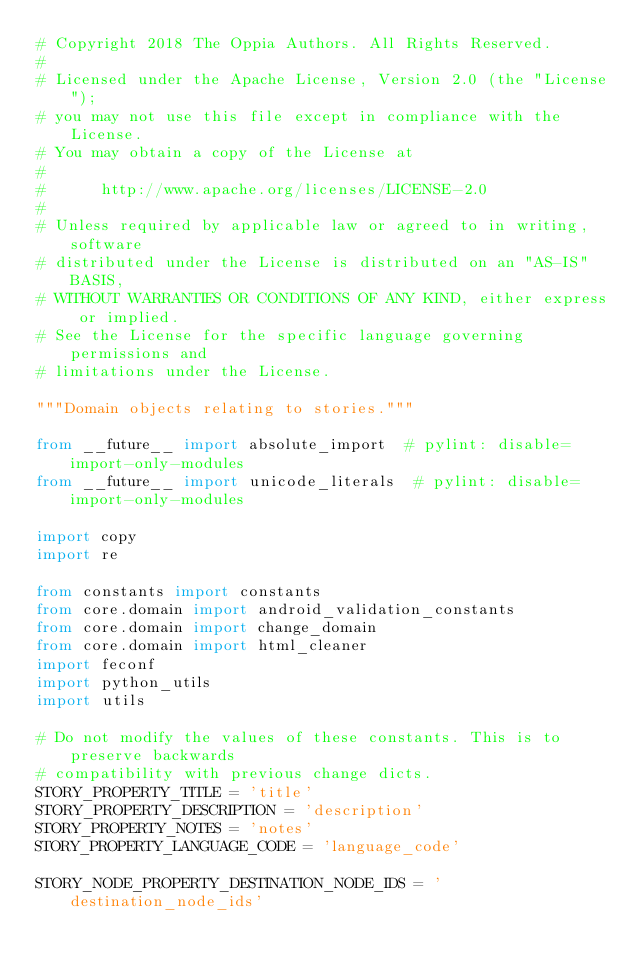<code> <loc_0><loc_0><loc_500><loc_500><_Python_># Copyright 2018 The Oppia Authors. All Rights Reserved.
#
# Licensed under the Apache License, Version 2.0 (the "License");
# you may not use this file except in compliance with the License.
# You may obtain a copy of the License at
#
#      http://www.apache.org/licenses/LICENSE-2.0
#
# Unless required by applicable law or agreed to in writing, software
# distributed under the License is distributed on an "AS-IS" BASIS,
# WITHOUT WARRANTIES OR CONDITIONS OF ANY KIND, either express or implied.
# See the License for the specific language governing permissions and
# limitations under the License.

"""Domain objects relating to stories."""

from __future__ import absolute_import  # pylint: disable=import-only-modules
from __future__ import unicode_literals  # pylint: disable=import-only-modules

import copy
import re

from constants import constants
from core.domain import android_validation_constants
from core.domain import change_domain
from core.domain import html_cleaner
import feconf
import python_utils
import utils

# Do not modify the values of these constants. This is to preserve backwards
# compatibility with previous change dicts.
STORY_PROPERTY_TITLE = 'title'
STORY_PROPERTY_DESCRIPTION = 'description'
STORY_PROPERTY_NOTES = 'notes'
STORY_PROPERTY_LANGUAGE_CODE = 'language_code'

STORY_NODE_PROPERTY_DESTINATION_NODE_IDS = 'destination_node_ids'</code> 